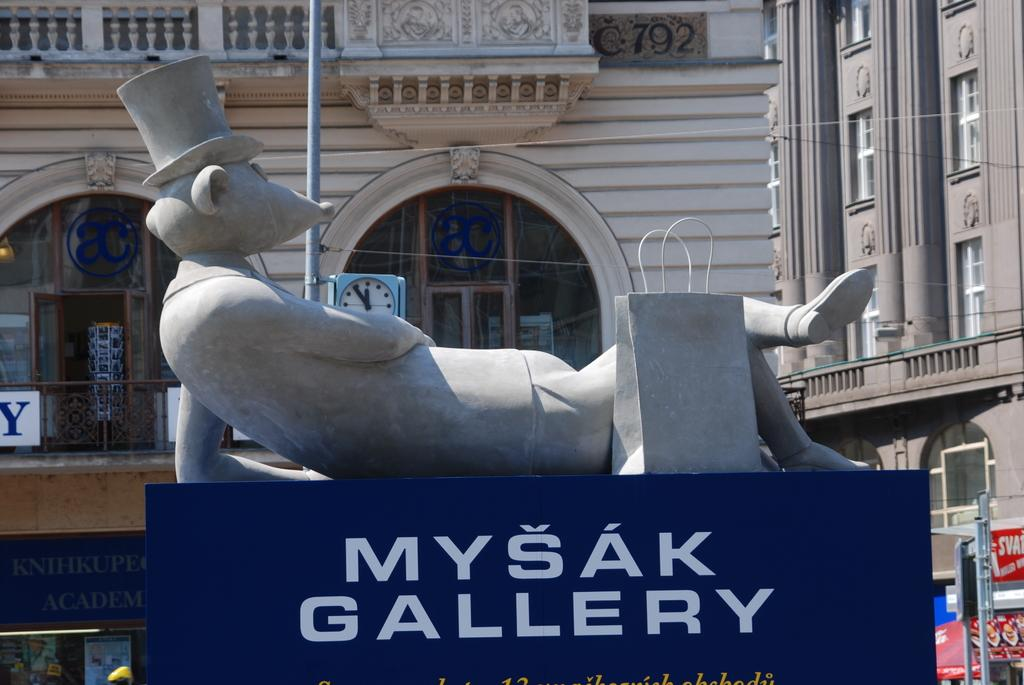What is the main subject in the image? There is a statue in the image. Is there any text or identification associated with the statue? Yes, there is a name board in the image. What can be seen in the distance behind the statue? There are buildings in the background of the image. Are there any other objects or features visible in the background? Yes, there are some objects visible in the background of the image. What type of fuel is being used by the zebra in the image? There is no zebra present in the image, and therefore no fuel usage can be observed. 